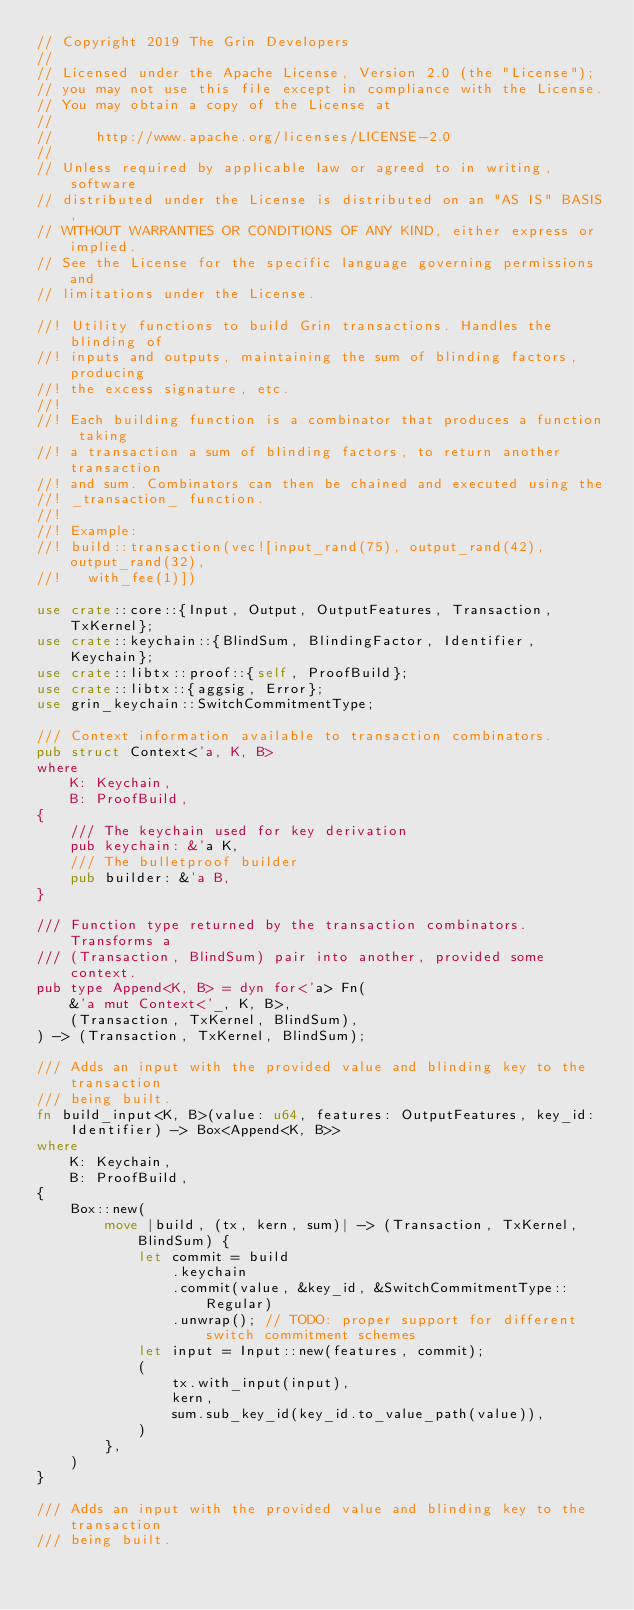<code> <loc_0><loc_0><loc_500><loc_500><_Rust_>// Copyright 2019 The Grin Developers
//
// Licensed under the Apache License, Version 2.0 (the "License");
// you may not use this file except in compliance with the License.
// You may obtain a copy of the License at
//
//     http://www.apache.org/licenses/LICENSE-2.0
//
// Unless required by applicable law or agreed to in writing, software
// distributed under the License is distributed on an "AS IS" BASIS,
// WITHOUT WARRANTIES OR CONDITIONS OF ANY KIND, either express or implied.
// See the License for the specific language governing permissions and
// limitations under the License.

//! Utility functions to build Grin transactions. Handles the blinding of
//! inputs and outputs, maintaining the sum of blinding factors, producing
//! the excess signature, etc.
//!
//! Each building function is a combinator that produces a function taking
//! a transaction a sum of blinding factors, to return another transaction
//! and sum. Combinators can then be chained and executed using the
//! _transaction_ function.
//!
//! Example:
//! build::transaction(vec![input_rand(75), output_rand(42), output_rand(32),
//!   with_fee(1)])

use crate::core::{Input, Output, OutputFeatures, Transaction, TxKernel};
use crate::keychain::{BlindSum, BlindingFactor, Identifier, Keychain};
use crate::libtx::proof::{self, ProofBuild};
use crate::libtx::{aggsig, Error};
use grin_keychain::SwitchCommitmentType;

/// Context information available to transaction combinators.
pub struct Context<'a, K, B>
where
	K: Keychain,
	B: ProofBuild,
{
	/// The keychain used for key derivation
	pub keychain: &'a K,
	/// The bulletproof builder
	pub builder: &'a B,
}

/// Function type returned by the transaction combinators. Transforms a
/// (Transaction, BlindSum) pair into another, provided some context.
pub type Append<K, B> = dyn for<'a> Fn(
	&'a mut Context<'_, K, B>,
	(Transaction, TxKernel, BlindSum),
) -> (Transaction, TxKernel, BlindSum);

/// Adds an input with the provided value and blinding key to the transaction
/// being built.
fn build_input<K, B>(value: u64, features: OutputFeatures, key_id: Identifier) -> Box<Append<K, B>>
where
	K: Keychain,
	B: ProofBuild,
{
	Box::new(
		move |build, (tx, kern, sum)| -> (Transaction, TxKernel, BlindSum) {
			let commit = build
				.keychain
				.commit(value, &key_id, &SwitchCommitmentType::Regular)
				.unwrap(); // TODO: proper support for different switch commitment schemes
			let input = Input::new(features, commit);
			(
				tx.with_input(input),
				kern,
				sum.sub_key_id(key_id.to_value_path(value)),
			)
		},
	)
}

/// Adds an input with the provided value and blinding key to the transaction
/// being built.</code> 